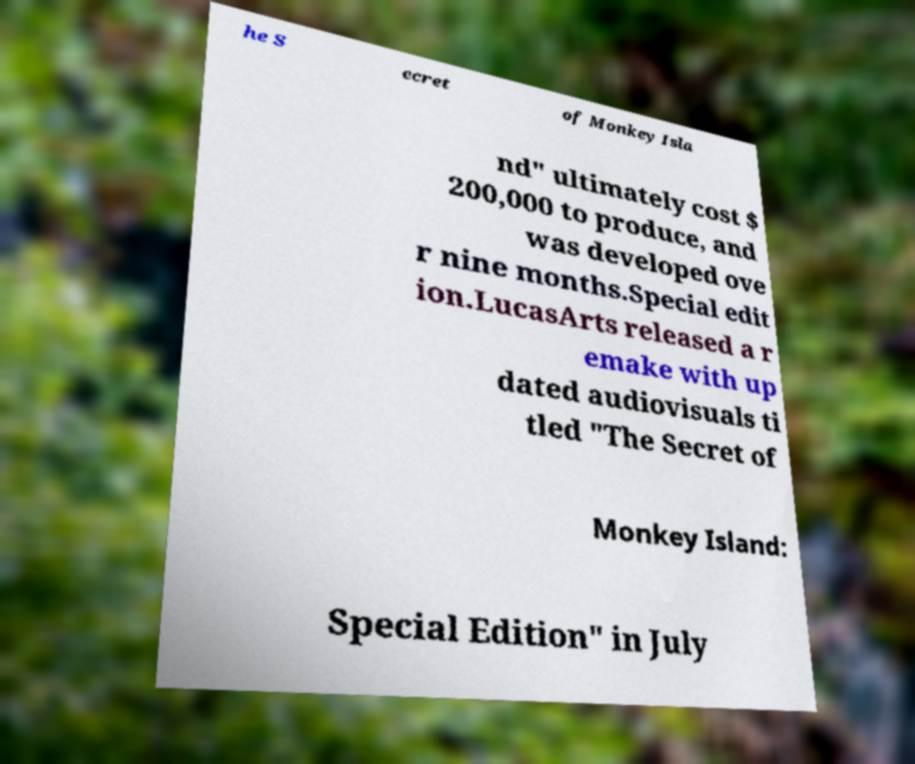Could you extract and type out the text from this image? he S ecret of Monkey Isla nd" ultimately cost $ 200,000 to produce, and was developed ove r nine months.Special edit ion.LucasArts released a r emake with up dated audiovisuals ti tled "The Secret of Monkey Island: Special Edition" in July 